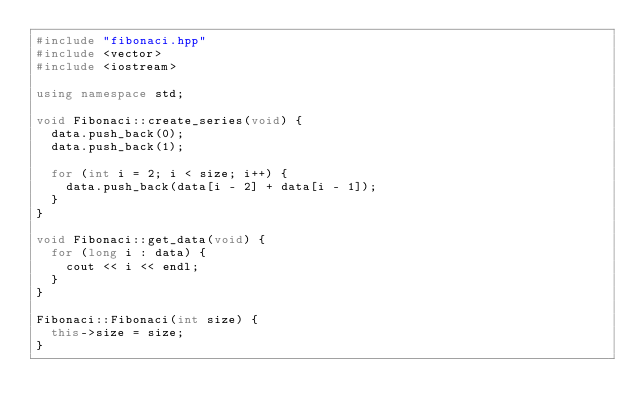Convert code to text. <code><loc_0><loc_0><loc_500><loc_500><_C++_>#include "fibonaci.hpp"
#include <vector>
#include <iostream>

using namespace std;

void Fibonaci::create_series(void) {
  data.push_back(0);
  data.push_back(1);

  for (int i = 2; i < size; i++) {
    data.push_back(data[i - 2] + data[i - 1]);
  }
}

void Fibonaci::get_data(void) {
  for (long i : data) {
    cout << i << endl;
  }
}

Fibonaci::Fibonaci(int size) {
  this->size = size;
}
</code> 